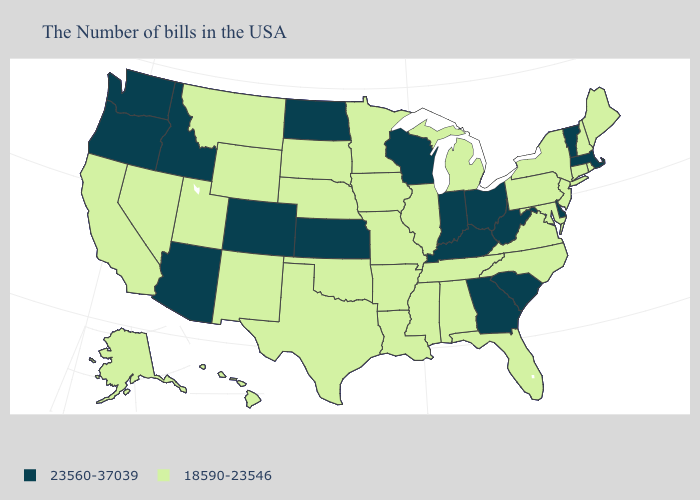Name the states that have a value in the range 18590-23546?
Quick response, please. Maine, Rhode Island, New Hampshire, Connecticut, New York, New Jersey, Maryland, Pennsylvania, Virginia, North Carolina, Florida, Michigan, Alabama, Tennessee, Illinois, Mississippi, Louisiana, Missouri, Arkansas, Minnesota, Iowa, Nebraska, Oklahoma, Texas, South Dakota, Wyoming, New Mexico, Utah, Montana, Nevada, California, Alaska, Hawaii. Does the first symbol in the legend represent the smallest category?
Write a very short answer. No. Among the states that border Indiana , does Ohio have the lowest value?
Be succinct. No. What is the value of Minnesota?
Keep it brief. 18590-23546. What is the value of Ohio?
Keep it brief. 23560-37039. What is the lowest value in the Northeast?
Be succinct. 18590-23546. What is the value of Florida?
Give a very brief answer. 18590-23546. What is the value of Indiana?
Short answer required. 23560-37039. Name the states that have a value in the range 18590-23546?
Write a very short answer. Maine, Rhode Island, New Hampshire, Connecticut, New York, New Jersey, Maryland, Pennsylvania, Virginia, North Carolina, Florida, Michigan, Alabama, Tennessee, Illinois, Mississippi, Louisiana, Missouri, Arkansas, Minnesota, Iowa, Nebraska, Oklahoma, Texas, South Dakota, Wyoming, New Mexico, Utah, Montana, Nevada, California, Alaska, Hawaii. Name the states that have a value in the range 18590-23546?
Concise answer only. Maine, Rhode Island, New Hampshire, Connecticut, New York, New Jersey, Maryland, Pennsylvania, Virginia, North Carolina, Florida, Michigan, Alabama, Tennessee, Illinois, Mississippi, Louisiana, Missouri, Arkansas, Minnesota, Iowa, Nebraska, Oklahoma, Texas, South Dakota, Wyoming, New Mexico, Utah, Montana, Nevada, California, Alaska, Hawaii. What is the value of Oklahoma?
Short answer required. 18590-23546. What is the lowest value in the Northeast?
Concise answer only. 18590-23546. Among the states that border Delaware , which have the highest value?
Answer briefly. New Jersey, Maryland, Pennsylvania. What is the value of Florida?
Concise answer only. 18590-23546. 